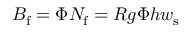Convert formula to latex. <formula><loc_0><loc_0><loc_500><loc_500>B _ { f } = \Phi N _ { f } = R g \Phi h w _ { s }</formula> 